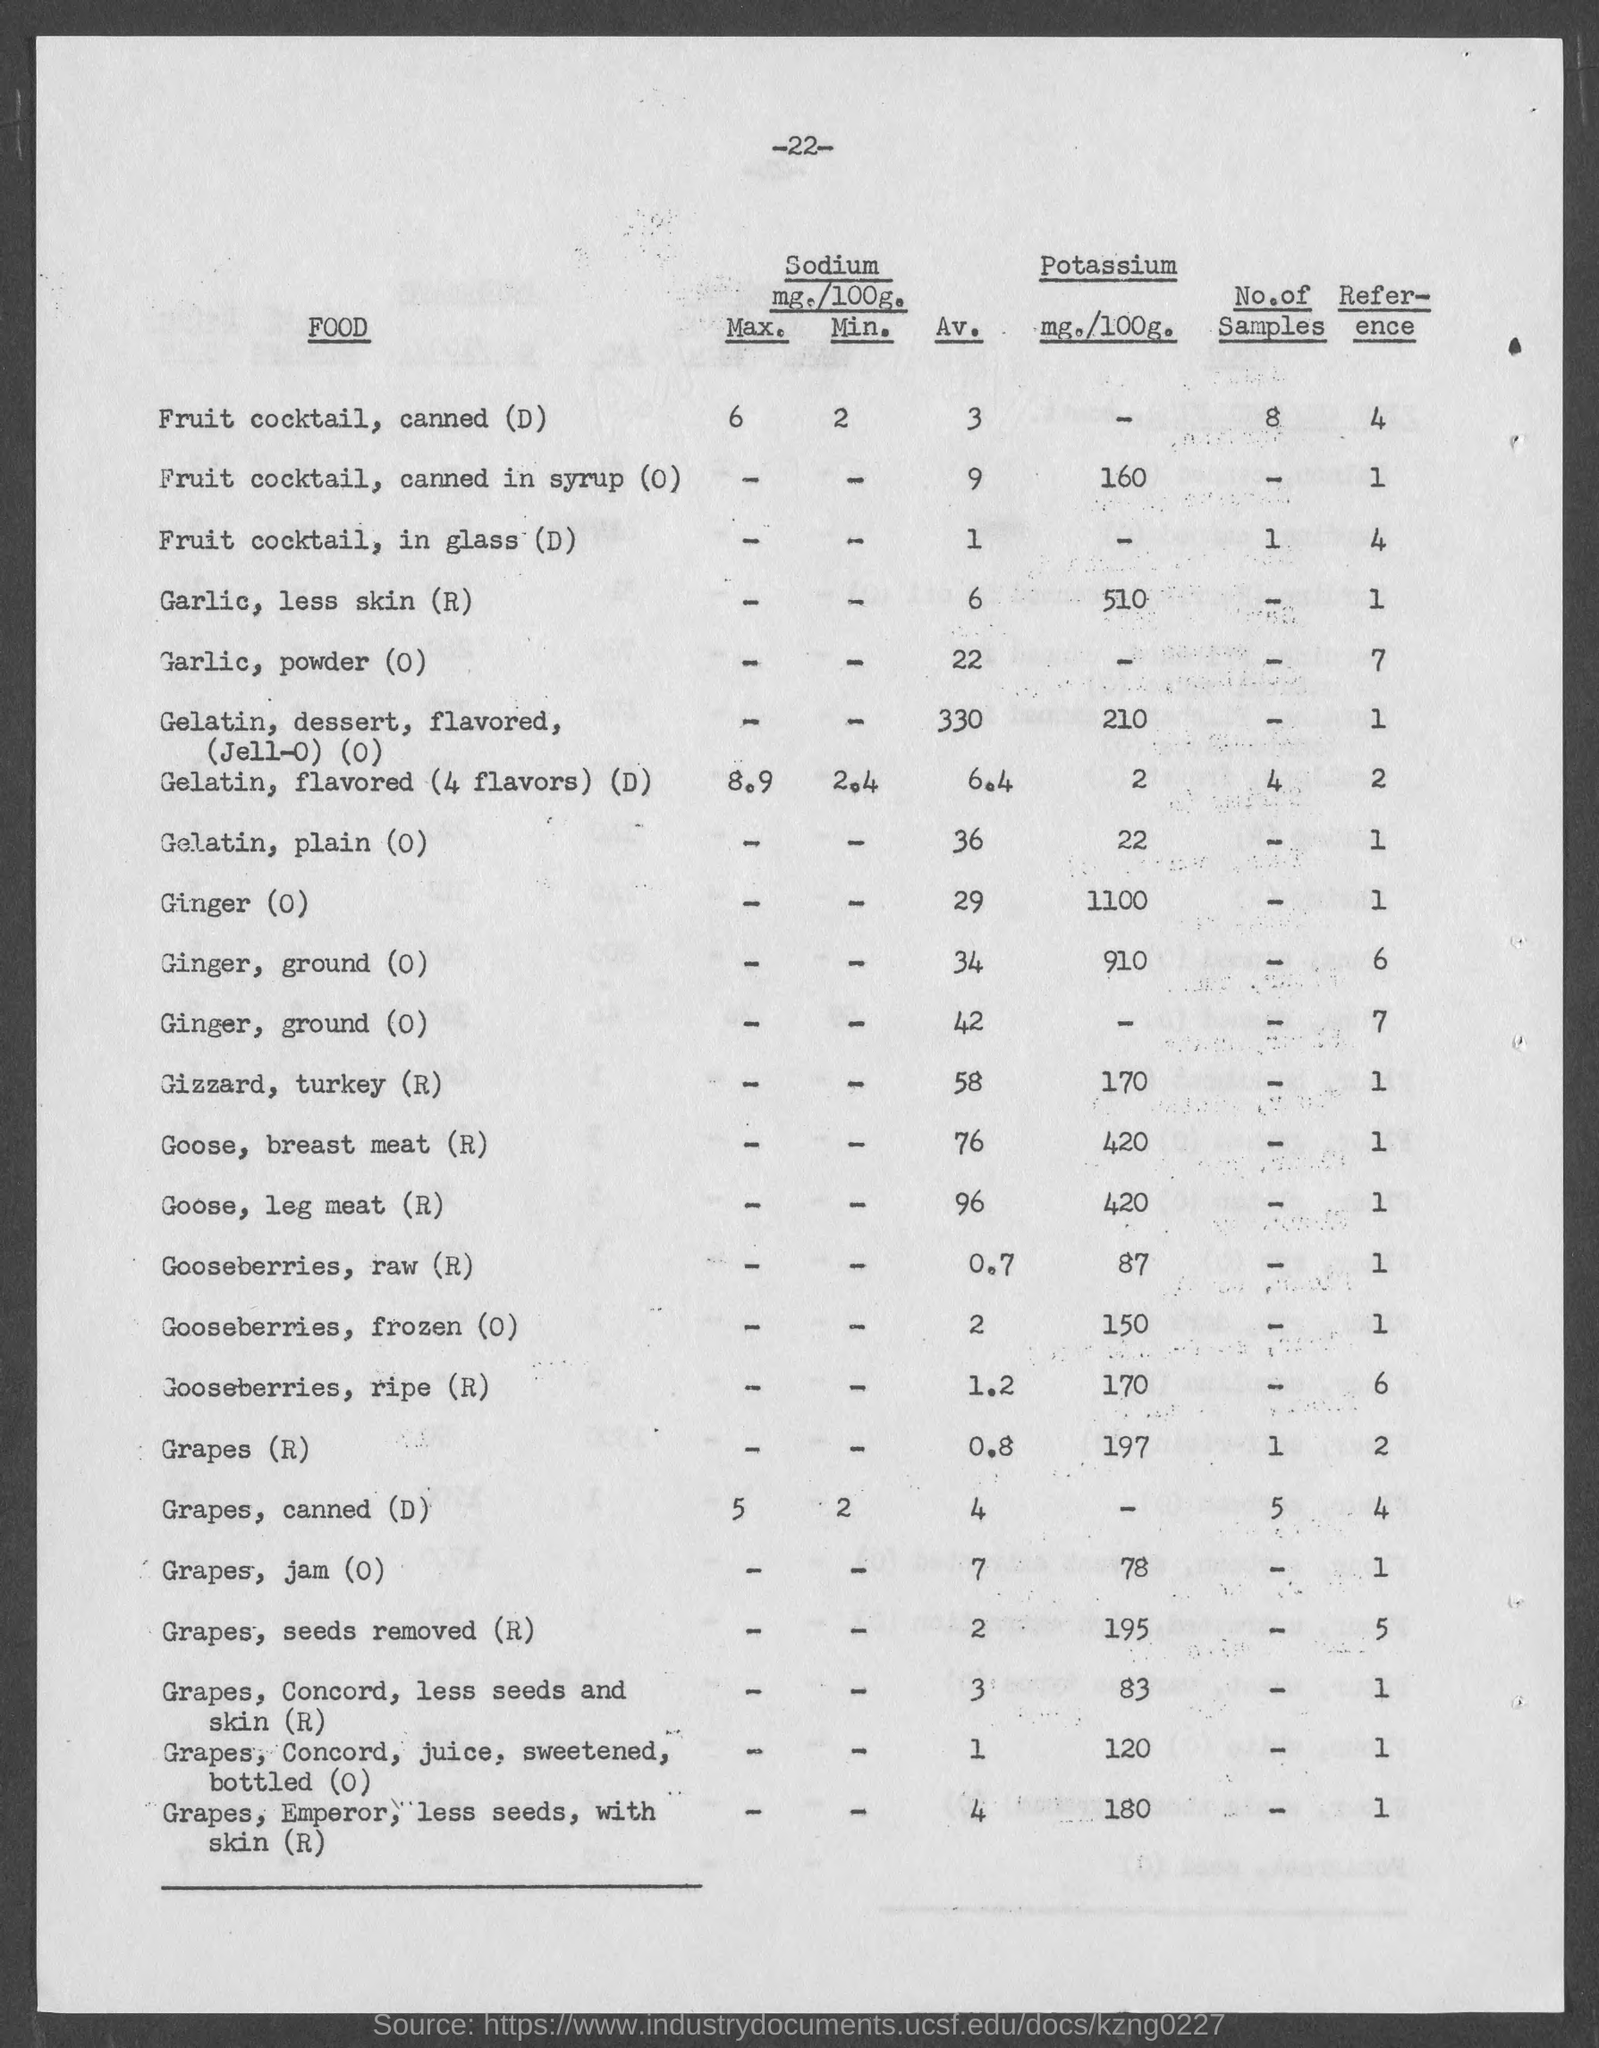What is the amount of potassium mg./100g.  for fruit cocktail, canned in syrup?
Keep it short and to the point. 160. What is the amount of potassium mg./100g.  for garlic,less skin?
Make the answer very short. 510. What is the amount of potassium mg./100g.  for gelatin, plain ?
Offer a terse response. 22. What is the amount of potassium mg./100g.  for ginger?
Ensure brevity in your answer.  1100. What is the amount of potassium mg./100g.  for gizzard, turkey?
Provide a succinct answer. 170. What is the amount of potassium mg./100g.  for goose, breast meat?
Your response must be concise. 420. What is the amount of potassium mg./100g.  for goose, leg meat?
Offer a very short reply. 420. What is the amount of potassium mg./100g.  for gooseberries, raw?
Give a very brief answer. 87. What is the amount of potassium mg./100g.  for gooseberries, frozen?
Keep it short and to the point. 150. What is the amount of potassium mg./100g.  for gooseberries, ripe ?
Your answer should be compact. 170. 